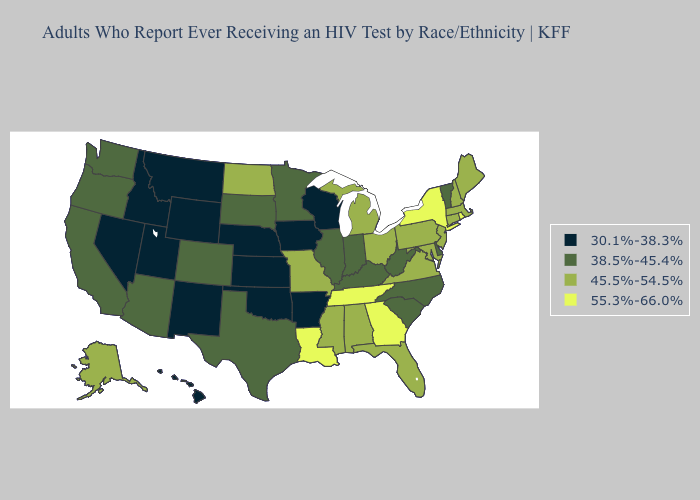What is the value of Louisiana?
Short answer required. 55.3%-66.0%. Does Colorado have the lowest value in the West?
Concise answer only. No. Does California have the lowest value in the West?
Be succinct. No. Does Washington have the highest value in the USA?
Answer briefly. No. What is the value of Arizona?
Keep it brief. 38.5%-45.4%. Name the states that have a value in the range 38.5%-45.4%?
Short answer required. Arizona, California, Colorado, Delaware, Illinois, Indiana, Kentucky, Minnesota, North Carolina, Oregon, South Carolina, South Dakota, Texas, Vermont, Washington, West Virginia. What is the lowest value in the USA?
Answer briefly. 30.1%-38.3%. Name the states that have a value in the range 38.5%-45.4%?
Be succinct. Arizona, California, Colorado, Delaware, Illinois, Indiana, Kentucky, Minnesota, North Carolina, Oregon, South Carolina, South Dakota, Texas, Vermont, Washington, West Virginia. Which states have the highest value in the USA?
Short answer required. Georgia, Louisiana, New York, Rhode Island, Tennessee. Does the map have missing data?
Short answer required. No. What is the value of Colorado?
Short answer required. 38.5%-45.4%. Among the states that border Illinois , does Kentucky have the lowest value?
Write a very short answer. No. Name the states that have a value in the range 45.5%-54.5%?
Answer briefly. Alabama, Alaska, Connecticut, Florida, Maine, Maryland, Massachusetts, Michigan, Mississippi, Missouri, New Hampshire, New Jersey, North Dakota, Ohio, Pennsylvania, Virginia. How many symbols are there in the legend?
Give a very brief answer. 4. Which states have the lowest value in the USA?
Give a very brief answer. Arkansas, Hawaii, Idaho, Iowa, Kansas, Montana, Nebraska, Nevada, New Mexico, Oklahoma, Utah, Wisconsin, Wyoming. 